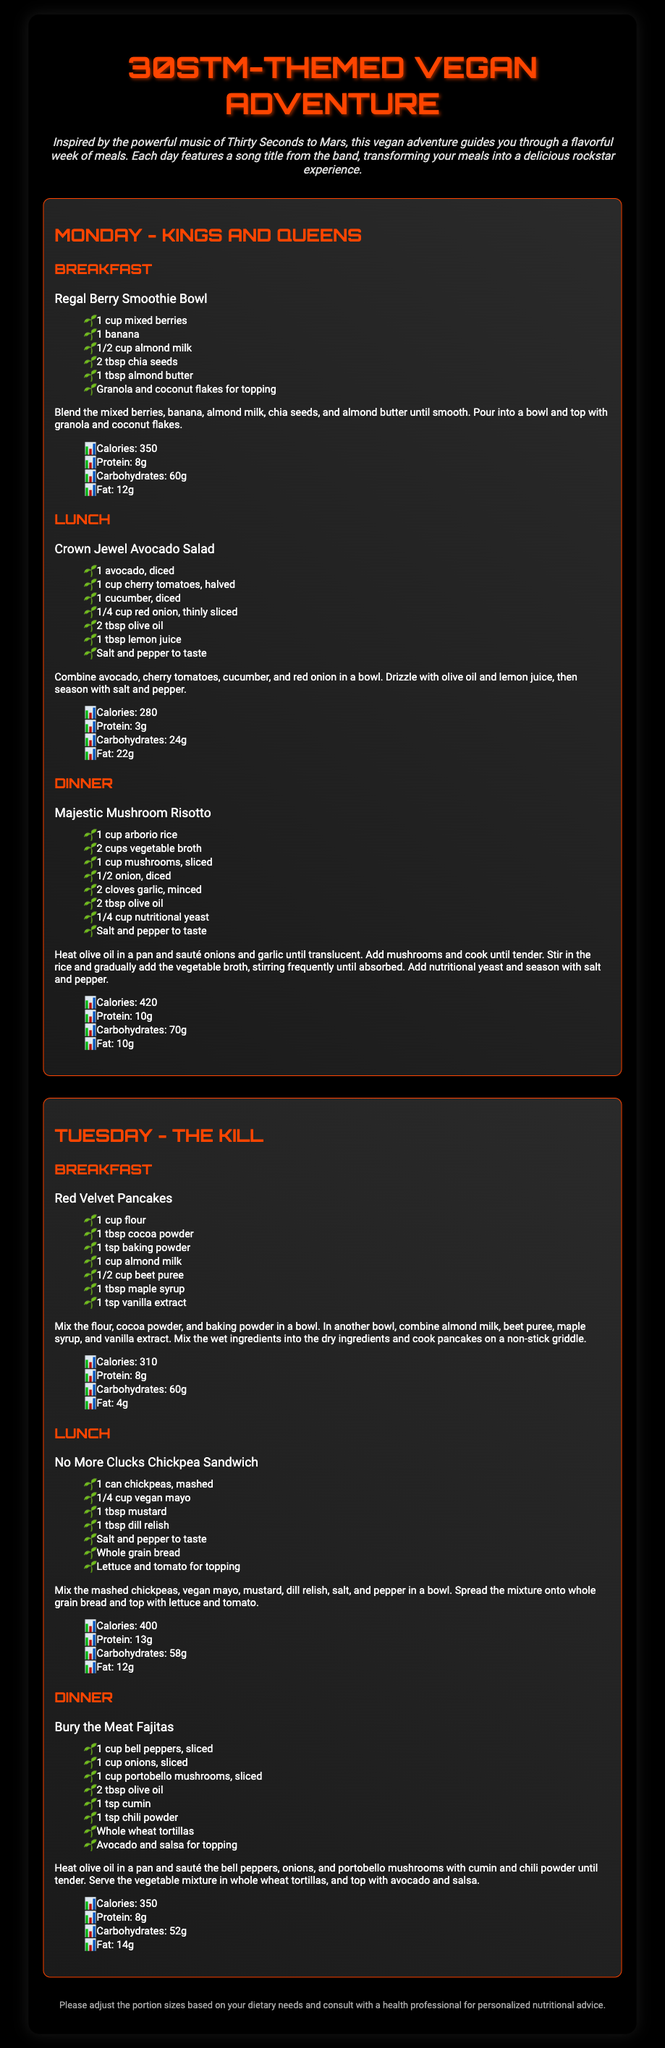What is the name of the breakfast for Monday? The document lists the breakfast for Monday as "Regal Berry Smoothie Bowl."
Answer: Regal Berry Smoothie Bowl How many calories are in the Majestic Mushroom Risotto? The nutritional information states that the Majestic Mushroom Risotto contains 420 calories.
Answer: 420 What is the main ingredient in the Crown Jewel Avocado Salad? The main ingredient is avocado, which is explicitly mentioned in the ingredients list for the salad.
Answer: Avocado How many meals are listed for Tuesday? The document describes three meals (breakfast, lunch, dinner) for Tuesday.
Answer: Three What is the total amount of protein in the Red Velvet Pancakes? According to the nutritional info, the Red Velvet Pancakes contain 8 grams of protein.
Answer: 8g Which song title is associated with Tuesday's breakfast? The Tuesday breakfast is linked to the song title "The Kill."
Answer: The Kill What topping is suggested for the Regal Berry Smoothie Bowl? It suggests granola and coconut flakes as toppings for the smoothie bowl.
Answer: Granola and coconut flakes How many grams of fat are in the No More Clucks Chickpea Sandwich? The nutritional information states that the Chickpea Sandwich contains 12 grams of fat.
Answer: 12g 